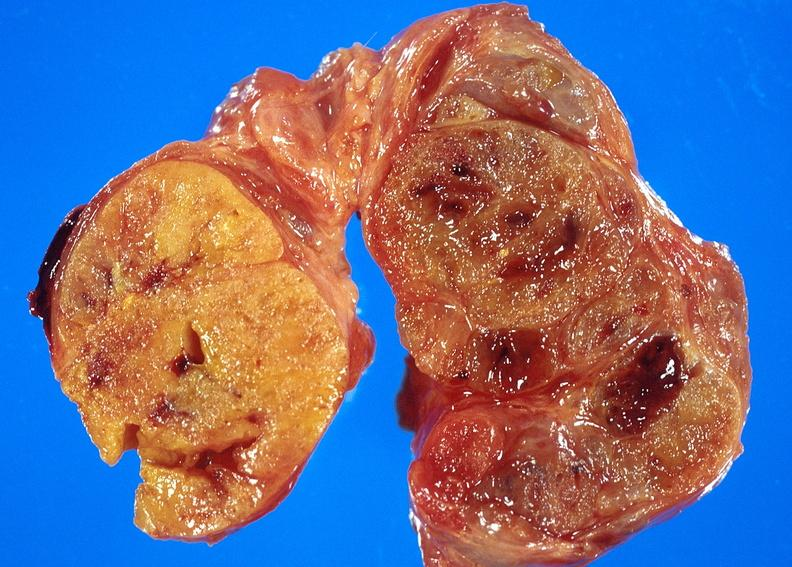s adenoma present?
Answer the question using a single word or phrase. No 